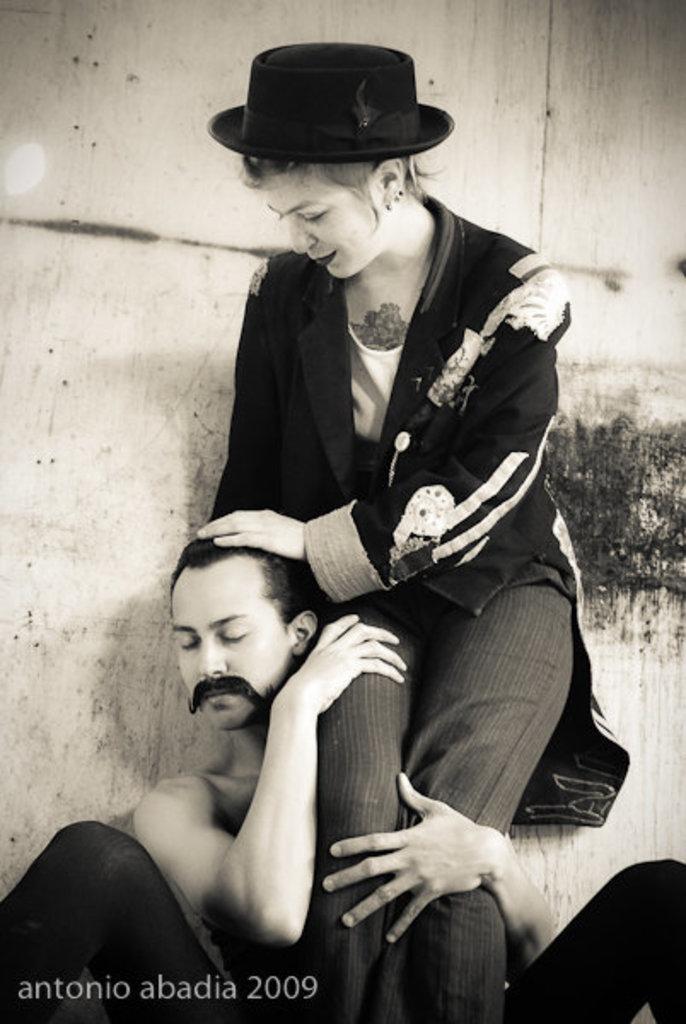How would you summarize this image in a sentence or two? In this image we can see black and white picture of people. One person is sitting and one woman is standing beside him. In the bottom left side of the image we can see some text. In the background, we can see a wall. 